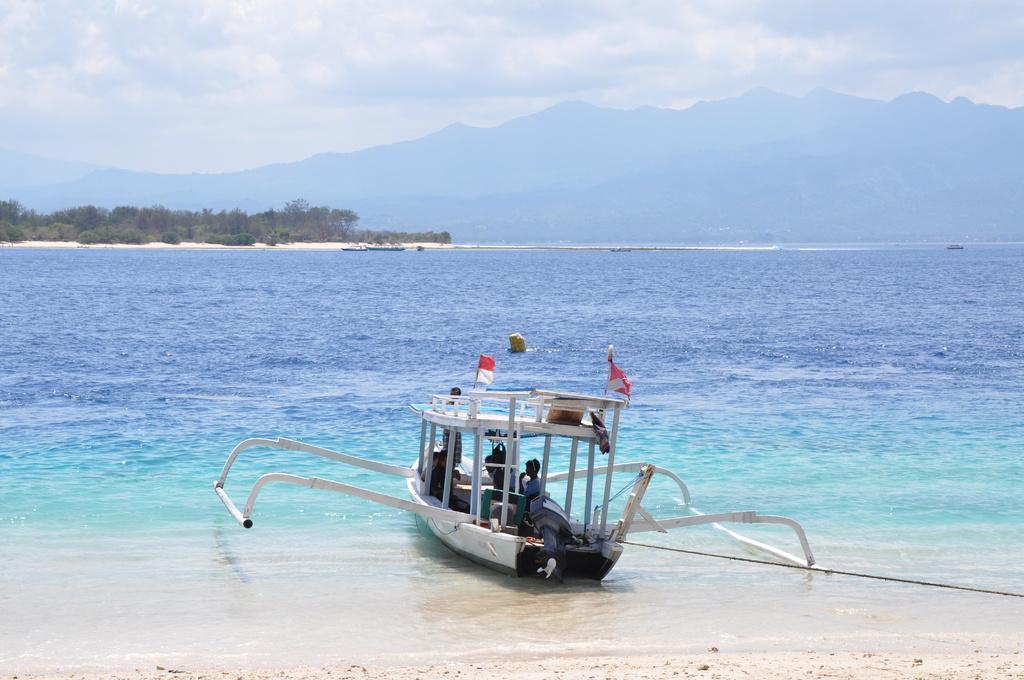Could you give a brief overview of what you see in this image? This picture is clicked outside the city. In the center we can see some persons and some objects in the boat and we can see the flags and some objects in the water body. In the background we can see the sky, hills, trees and some objects. 